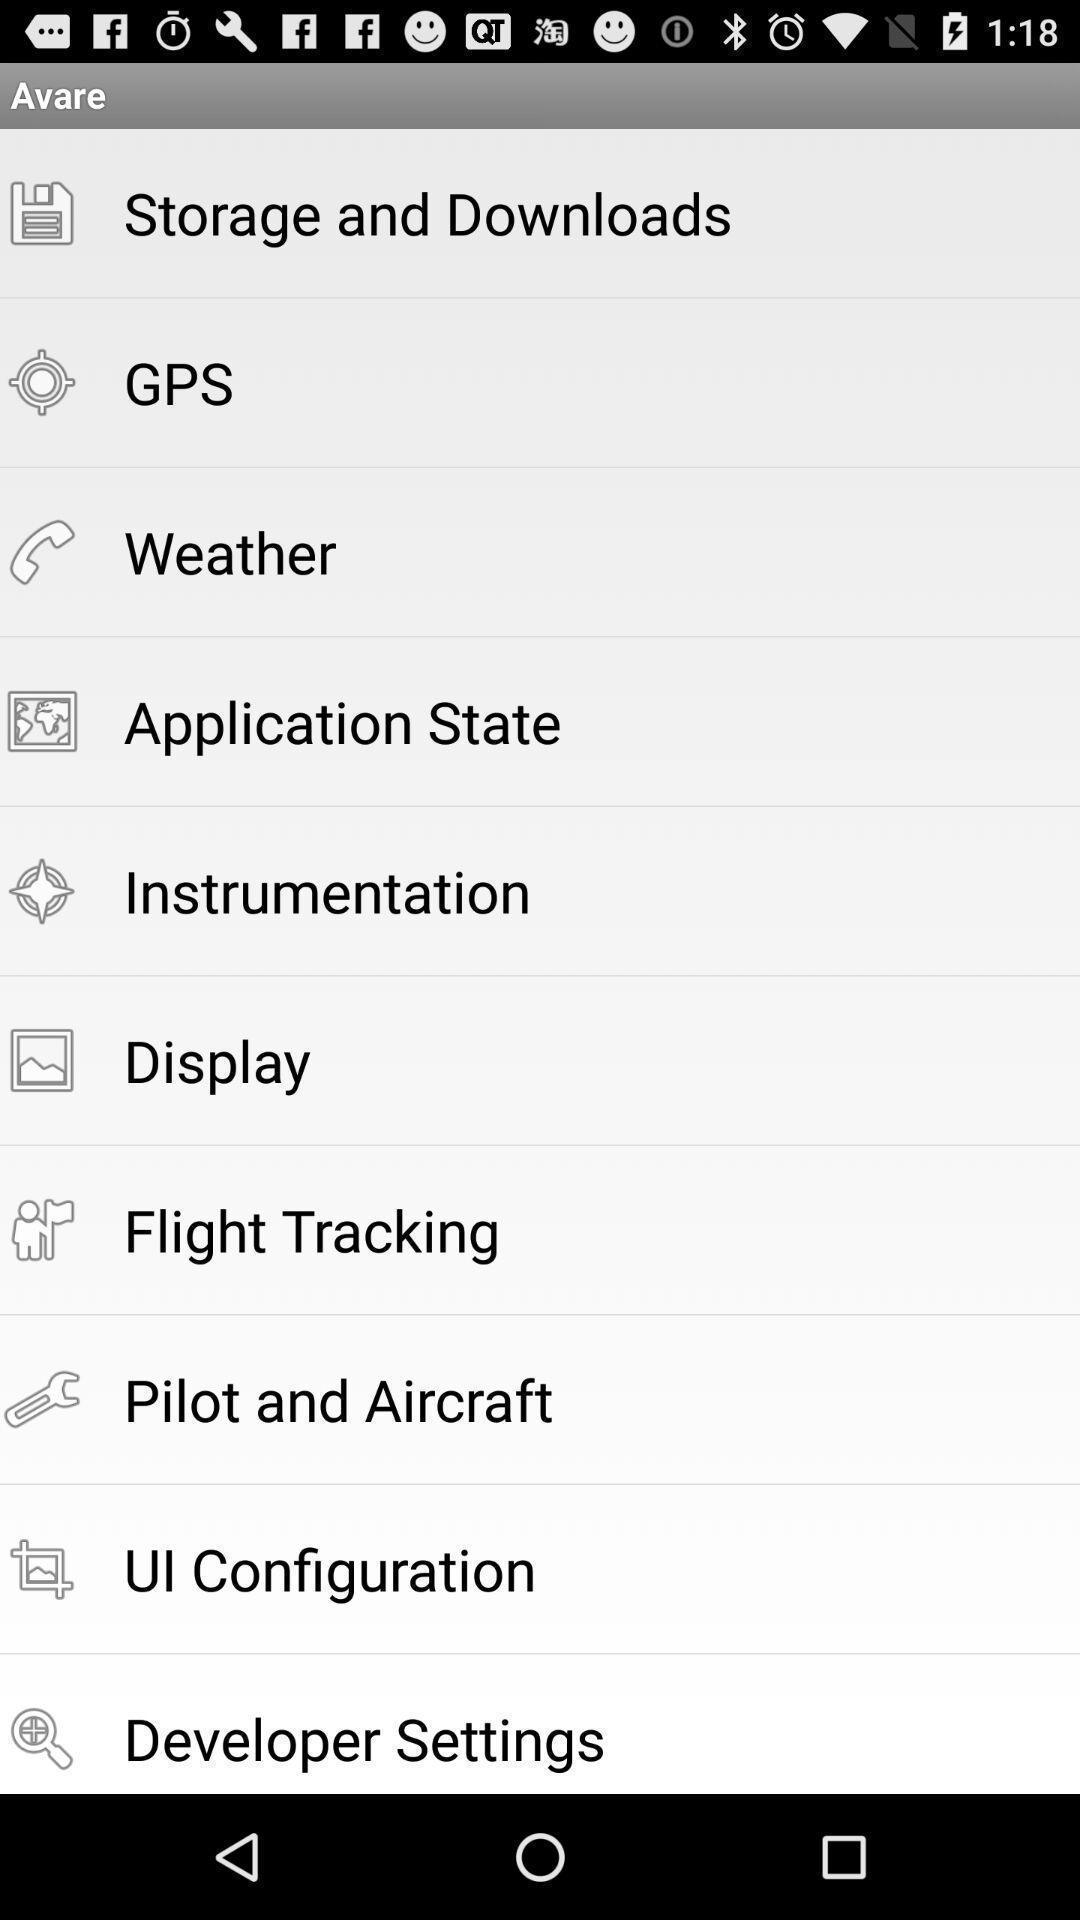Provide a textual representation of this image. Page showing options in a aviation related app. 